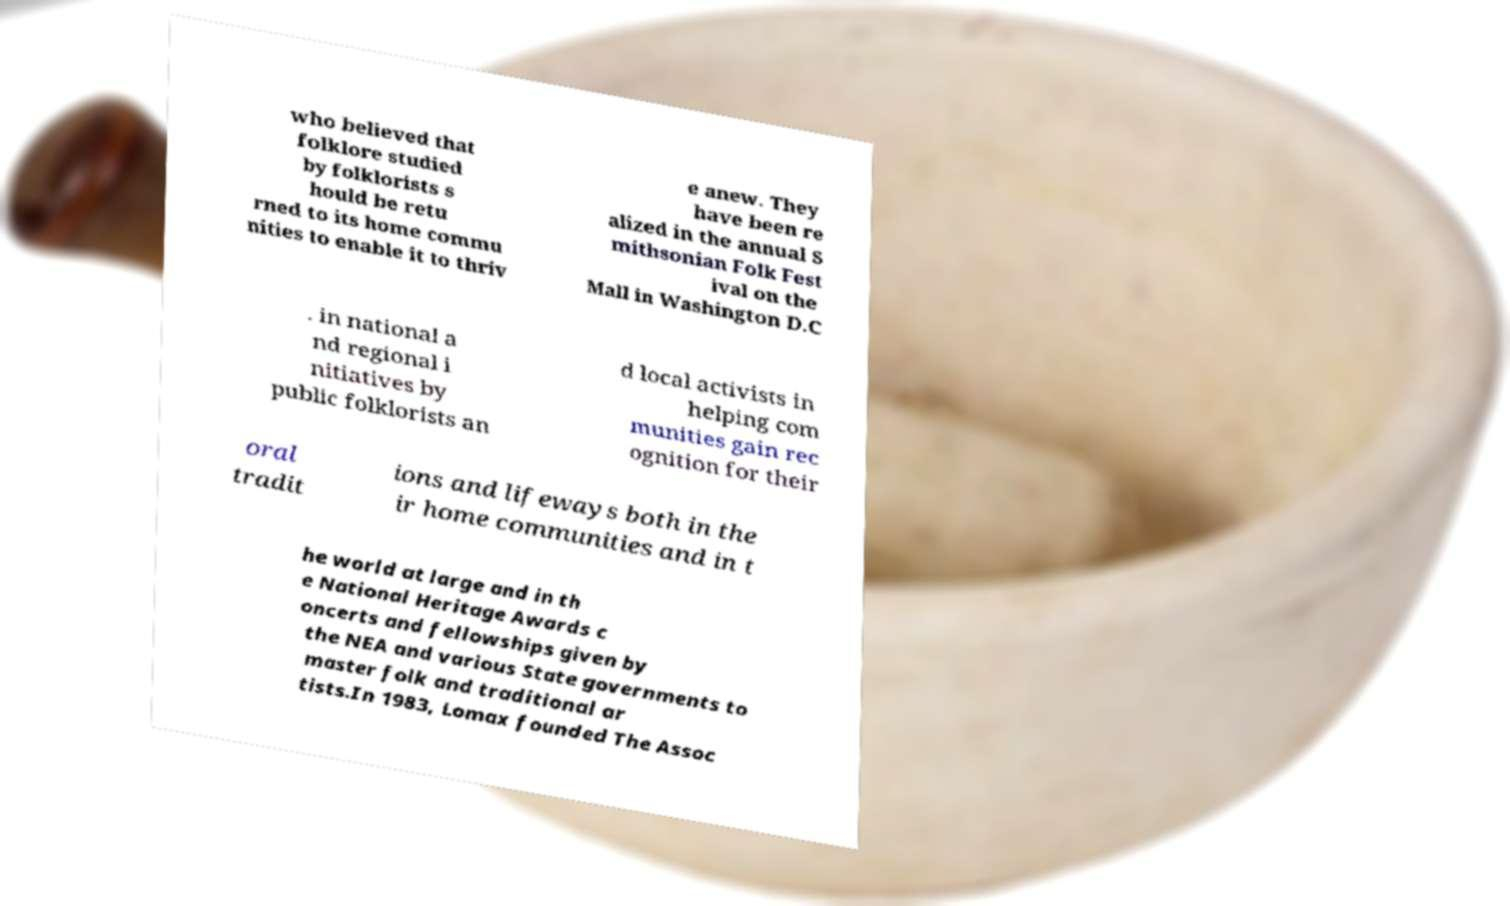Could you extract and type out the text from this image? who believed that folklore studied by folklorists s hould be retu rned to its home commu nities to enable it to thriv e anew. They have been re alized in the annual S mithsonian Folk Fest ival on the Mall in Washington D.C . in national a nd regional i nitiatives by public folklorists an d local activists in helping com munities gain rec ognition for their oral tradit ions and lifeways both in the ir home communities and in t he world at large and in th e National Heritage Awards c oncerts and fellowships given by the NEA and various State governments to master folk and traditional ar tists.In 1983, Lomax founded The Assoc 